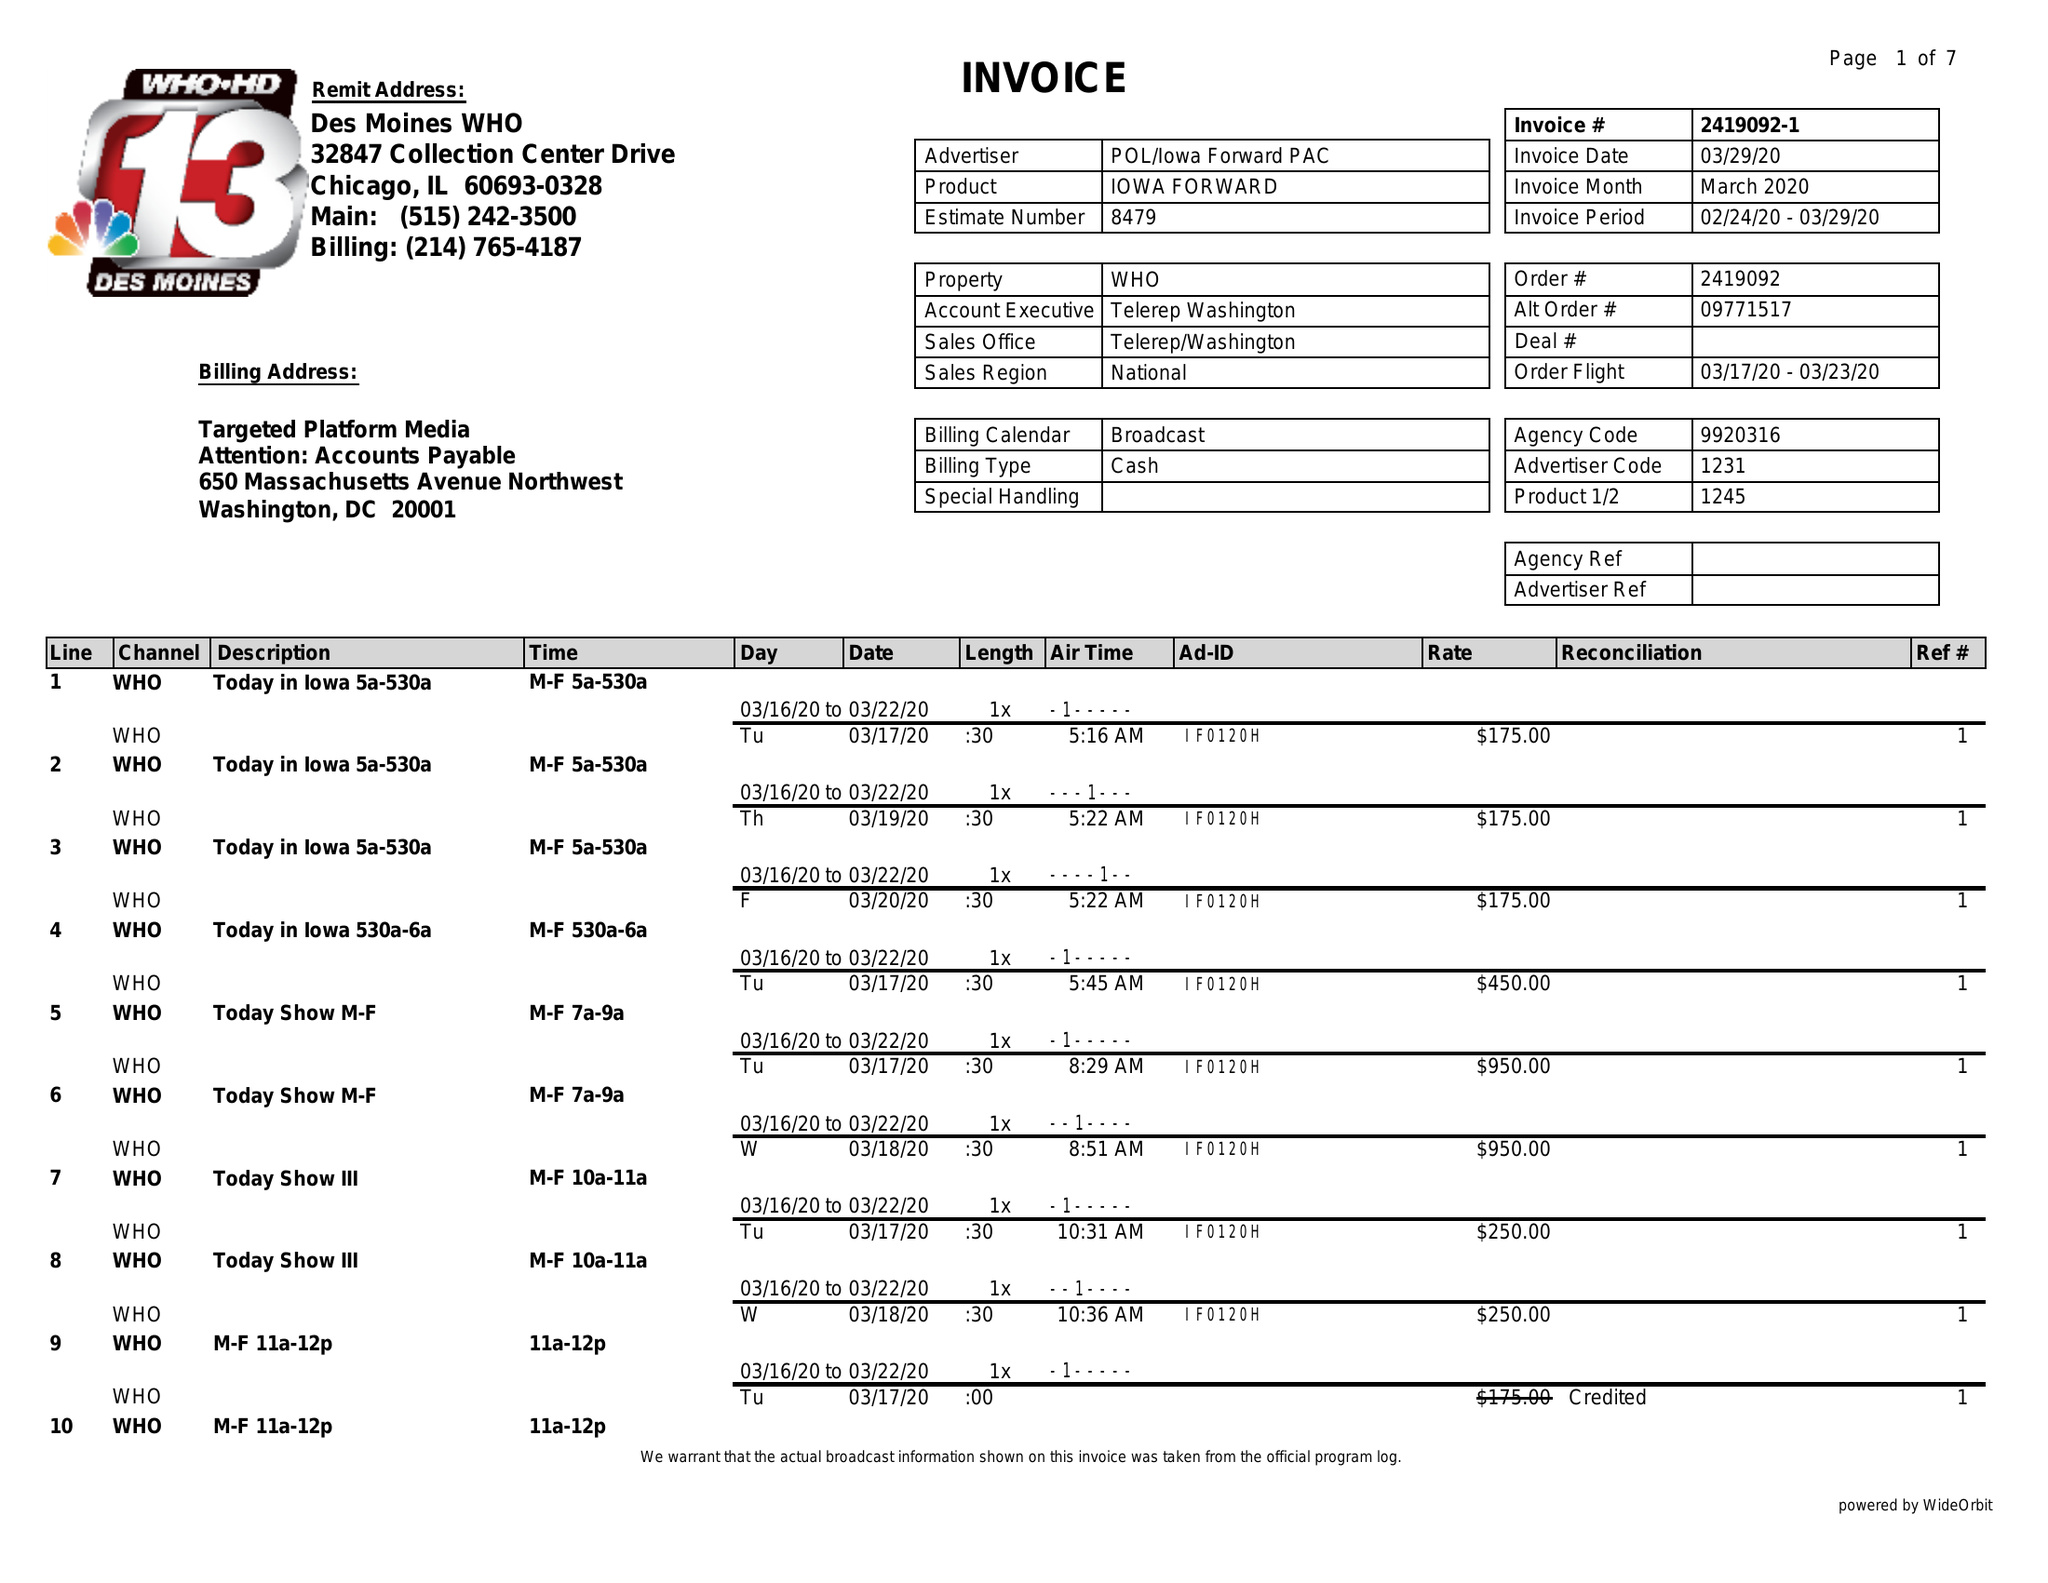What is the value for the contract_num?
Answer the question using a single word or phrase. 2419092 